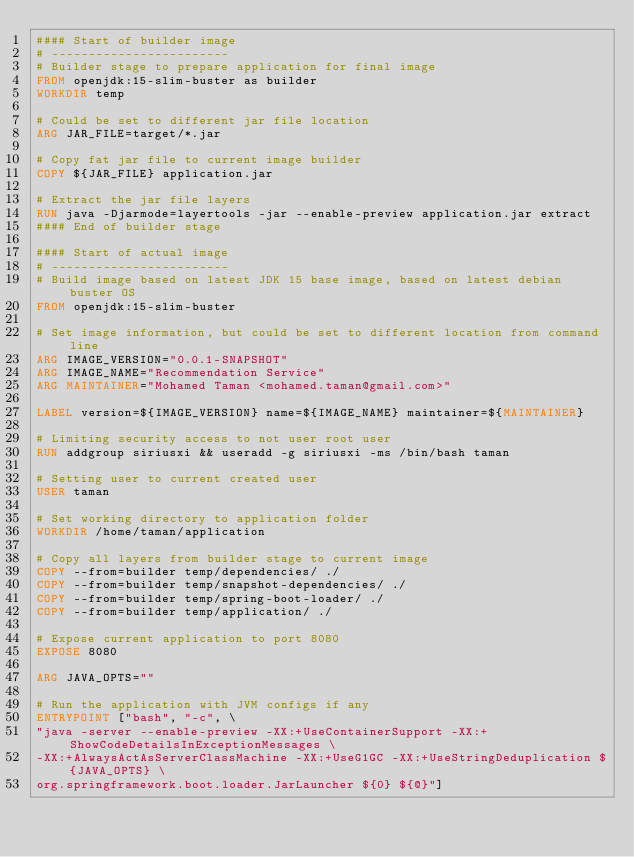<code> <loc_0><loc_0><loc_500><loc_500><_Dockerfile_>#### Start of builder image
# ------------------------
# Builder stage to prepare application for final image
FROM openjdk:15-slim-buster as builder
WORKDIR temp

# Could be set to different jar file location
ARG JAR_FILE=target/*.jar

# Copy fat jar file to current image builder
COPY ${JAR_FILE} application.jar

# Extract the jar file layers
RUN java -Djarmode=layertools -jar --enable-preview application.jar extract
#### End of builder stage

#### Start of actual image
# ------------------------
# Build image based on latest JDK 15 base image, based on latest debian buster OS
FROM openjdk:15-slim-buster

# Set image information, but could be set to different location from command line
ARG IMAGE_VERSION="0.0.1-SNAPSHOT"
ARG IMAGE_NAME="Recommendation Service"
ARG MAINTAINER="Mohamed Taman <mohamed.taman@gmail.com>"

LABEL version=${IMAGE_VERSION} name=${IMAGE_NAME} maintainer=${MAINTAINER}

# Limiting security access to not user root user
RUN addgroup siriusxi && useradd -g siriusxi -ms /bin/bash taman

# Setting user to current created user
USER taman

# Set working directory to application folder
WORKDIR /home/taman/application

# Copy all layers from builder stage to current image
COPY --from=builder temp/dependencies/ ./
COPY --from=builder temp/snapshot-dependencies/ ./
COPY --from=builder temp/spring-boot-loader/ ./
COPY --from=builder temp/application/ ./

# Expose current application to port 8080
EXPOSE 8080

ARG JAVA_OPTS=""

# Run the application with JVM configs if any
ENTRYPOINT ["bash", "-c", \
"java -server --enable-preview -XX:+UseContainerSupport -XX:+ShowCodeDetailsInExceptionMessages \
-XX:+AlwaysActAsServerClassMachine -XX:+UseG1GC -XX:+UseStringDeduplication ${JAVA_OPTS} \
org.springframework.boot.loader.JarLauncher ${0} ${@}"]</code> 